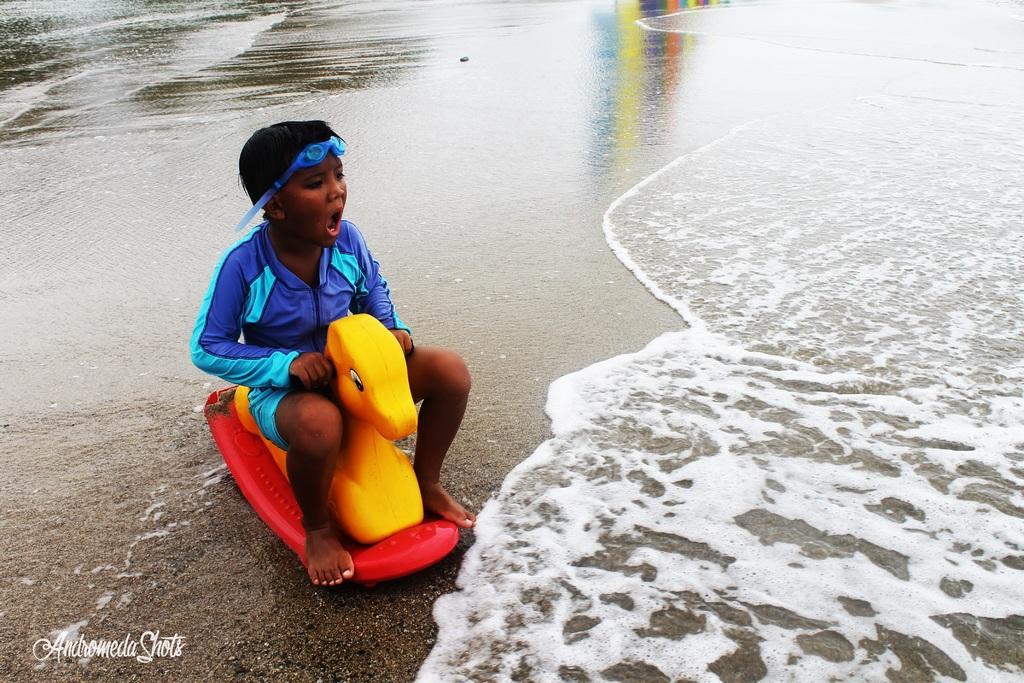Please provide a concise description of this image. In the image a boy is sitting on a toy and in front of him there is a sea. 